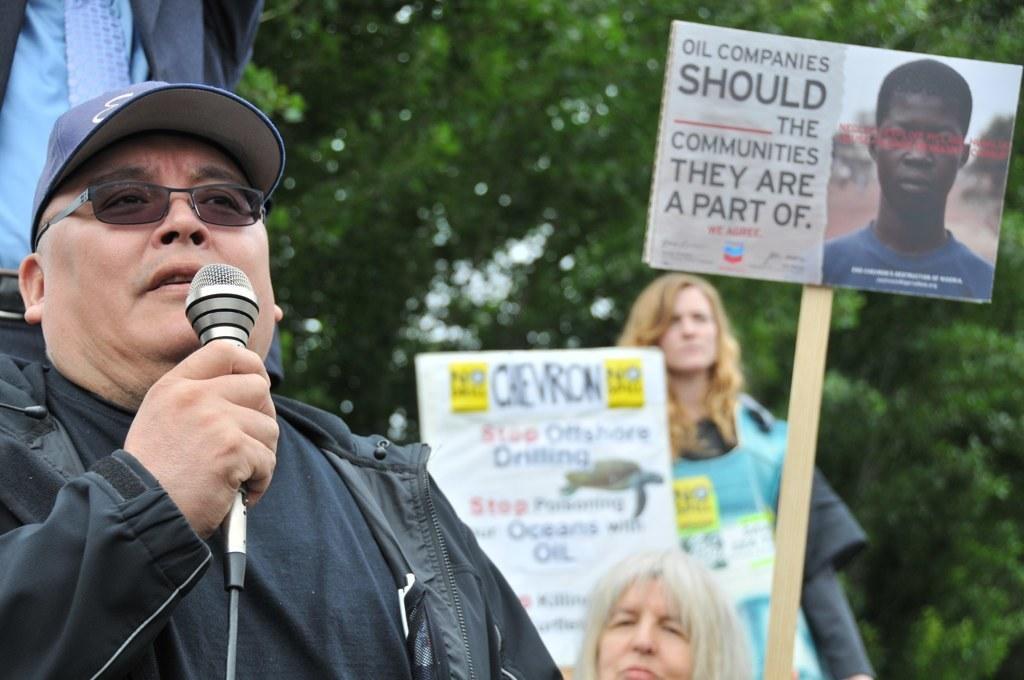Describe this image in one or two sentences. This image is clicked at outdoor. On the left there is a man he wear black jacket and t shirt he is holding a mic he is speaking. In the middle there are two women they are staring at something. In the right there is a poster. In the background there are many trees. 